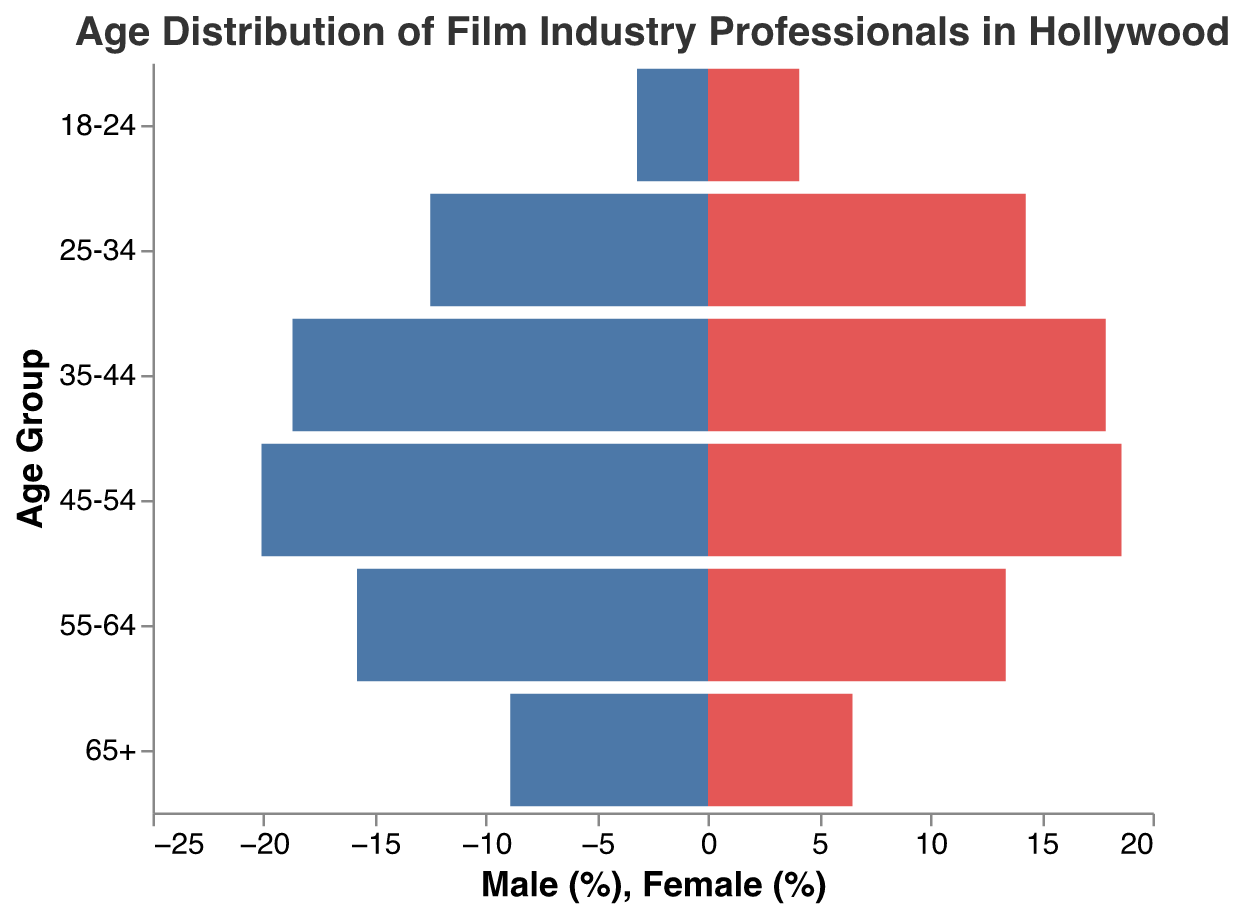What is the title of the figure? The title of the figure is usually in a prominent position and describes the overall content of the plot.
Answer: "Age Distribution of Film Industry Professionals in Hollywood" How many age groups are represented in the figure? By counting the distinct age groups listed on the y-axis, you can determine the number of age groups.
Answer: 6 Which age group has the highest percentage of males? Identify the age group on the y-axis that corresponds to the highest negative bar value.
Answer: 45-54 What is the difference in percentage between males and females in the 25-34 age group? Find the percentages for males and females in this age group and subtract the smaller percentage from the larger one.
Answer: 1.8 How does the percentage of males in the 65+ age group compare to that of females? Look at the bar lengths for the 65+ age group and compare their magnitudes.
Answer: Higher for males In which age group is the percentage of females the highest? Identify the age group on the y-axis that corresponds to the highest positive bar value.
Answer: 25-34 What is the overall trend in the percentage of males as age increases? Observe the progression of the negative bars (representing males) from the youngest to the oldest age groups.
Answer: Increases then decreases Is there any age group where the percentage of females is greater than that of males? Compare the lengths of bars for both genders within each age group to find if any female bar exceeds corresponding male bar.
Answer: Yes, 18-24 and 25-34 What's the total percentage of professionals aged 45-54 for both males and females? Add the male and female percentages for the 45-54 age group.
Answer: 38.7 Which gender has a more evenly distributed age demographic? Compare the distribution shape and range of bar lengths for both genders to determine which is more evenly spread.
Answer: Female 